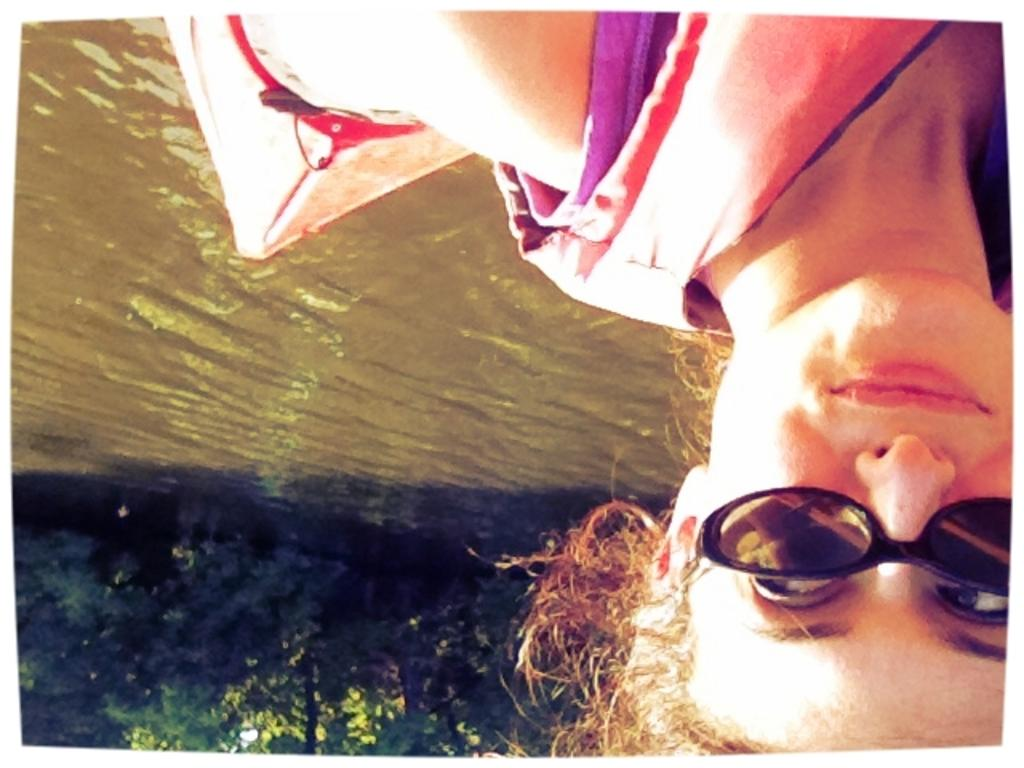Who is present in the image? There is a woman in the image. What is the woman doing in the image? The woman is smiling in the image. What can be seen above the water in the image? There is a boat above the water in the image. What type of natural environment is visible in the image? Trees are visible in the image. What type of songs can be heard coming from the boat in the image? There is no indication in the image that there are songs coming from the boat, so it cannot be determined from the picture. 